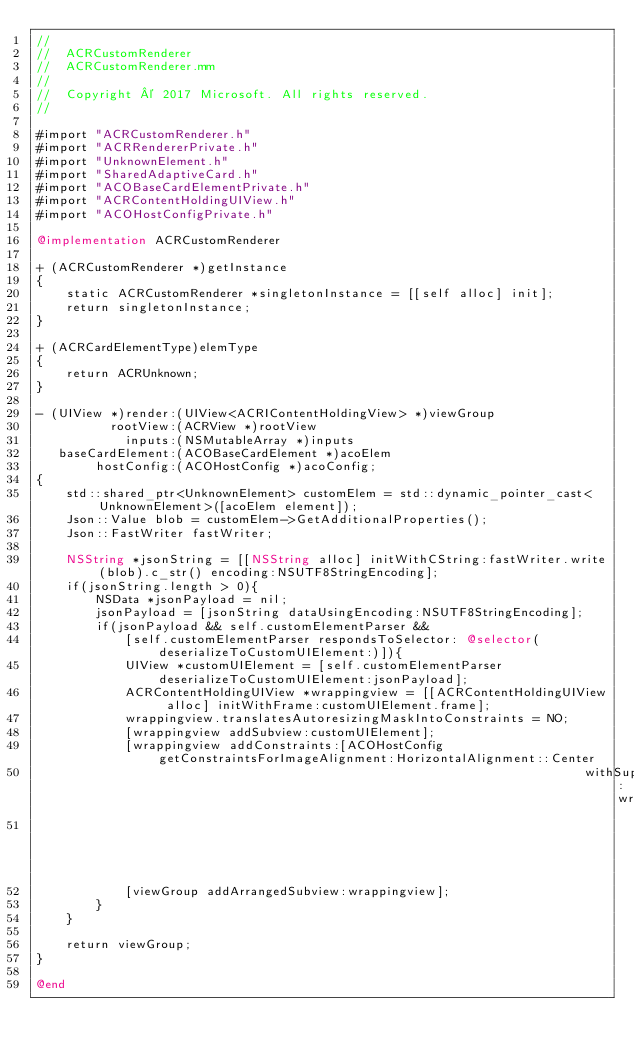Convert code to text. <code><loc_0><loc_0><loc_500><loc_500><_ObjectiveC_>//
//  ACRCustomRenderer
//  ACRCustomRenderer.mm
//
//  Copyright © 2017 Microsoft. All rights reserved.
//

#import "ACRCustomRenderer.h"
#import "ACRRendererPrivate.h"
#import "UnknownElement.h"
#import "SharedAdaptiveCard.h"
#import "ACOBaseCardElementPrivate.h"
#import "ACRContentHoldingUIView.h"
#import "ACOHostConfigPrivate.h"

@implementation ACRCustomRenderer

+ (ACRCustomRenderer *)getInstance
{
    static ACRCustomRenderer *singletonInstance = [[self alloc] init];
    return singletonInstance;
}

+ (ACRCardElementType)elemType
{
    return ACRUnknown;
}

- (UIView *)render:(UIView<ACRIContentHoldingView> *)viewGroup
          rootView:(ACRView *)rootView
            inputs:(NSMutableArray *)inputs
   baseCardElement:(ACOBaseCardElement *)acoElem
        hostConfig:(ACOHostConfig *)acoConfig;
{
    std::shared_ptr<UnknownElement> customElem = std::dynamic_pointer_cast<UnknownElement>([acoElem element]);
    Json::Value blob = customElem->GetAdditionalProperties();
    Json::FastWriter fastWriter;

    NSString *jsonString = [[NSString alloc] initWithCString:fastWriter.write(blob).c_str() encoding:NSUTF8StringEncoding];
    if(jsonString.length > 0){
        NSData *jsonPayload = nil;
        jsonPayload = [jsonString dataUsingEncoding:NSUTF8StringEncoding];
        if(jsonPayload && self.customElementParser &&
            [self.customElementParser respondsToSelector: @selector(deserializeToCustomUIElement:)]){
            UIView *customUIElement = [self.customElementParser deserializeToCustomUIElement:jsonPayload];
            ACRContentHoldingUIView *wrappingview = [[ACRContentHoldingUIView alloc] initWithFrame:customUIElement.frame];
            wrappingview.translatesAutoresizingMaskIntoConstraints = NO;
            [wrappingview addSubview:customUIElement];
            [wrappingview addConstraints:[ACOHostConfig getConstraintsForImageAlignment:HorizontalAlignment::Center
                                                                          withSuperview:wrappingview
                                                                                 toView:customUIElement]];
            [viewGroup addArrangedSubview:wrappingview];
        }
    }

    return viewGroup;
}

@end

</code> 